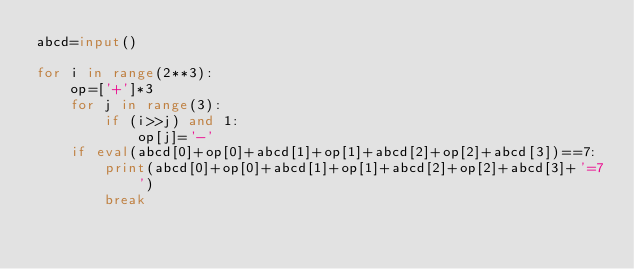Convert code to text. <code><loc_0><loc_0><loc_500><loc_500><_Python_>abcd=input()

for i in range(2**3):
    op=['+']*3
    for j in range(3):
        if (i>>j) and 1:
            op[j]='-'
    if eval(abcd[0]+op[0]+abcd[1]+op[1]+abcd[2]+op[2]+abcd[3])==7:
        print(abcd[0]+op[0]+abcd[1]+op[1]+abcd[2]+op[2]+abcd[3]+'=7')
        break</code> 